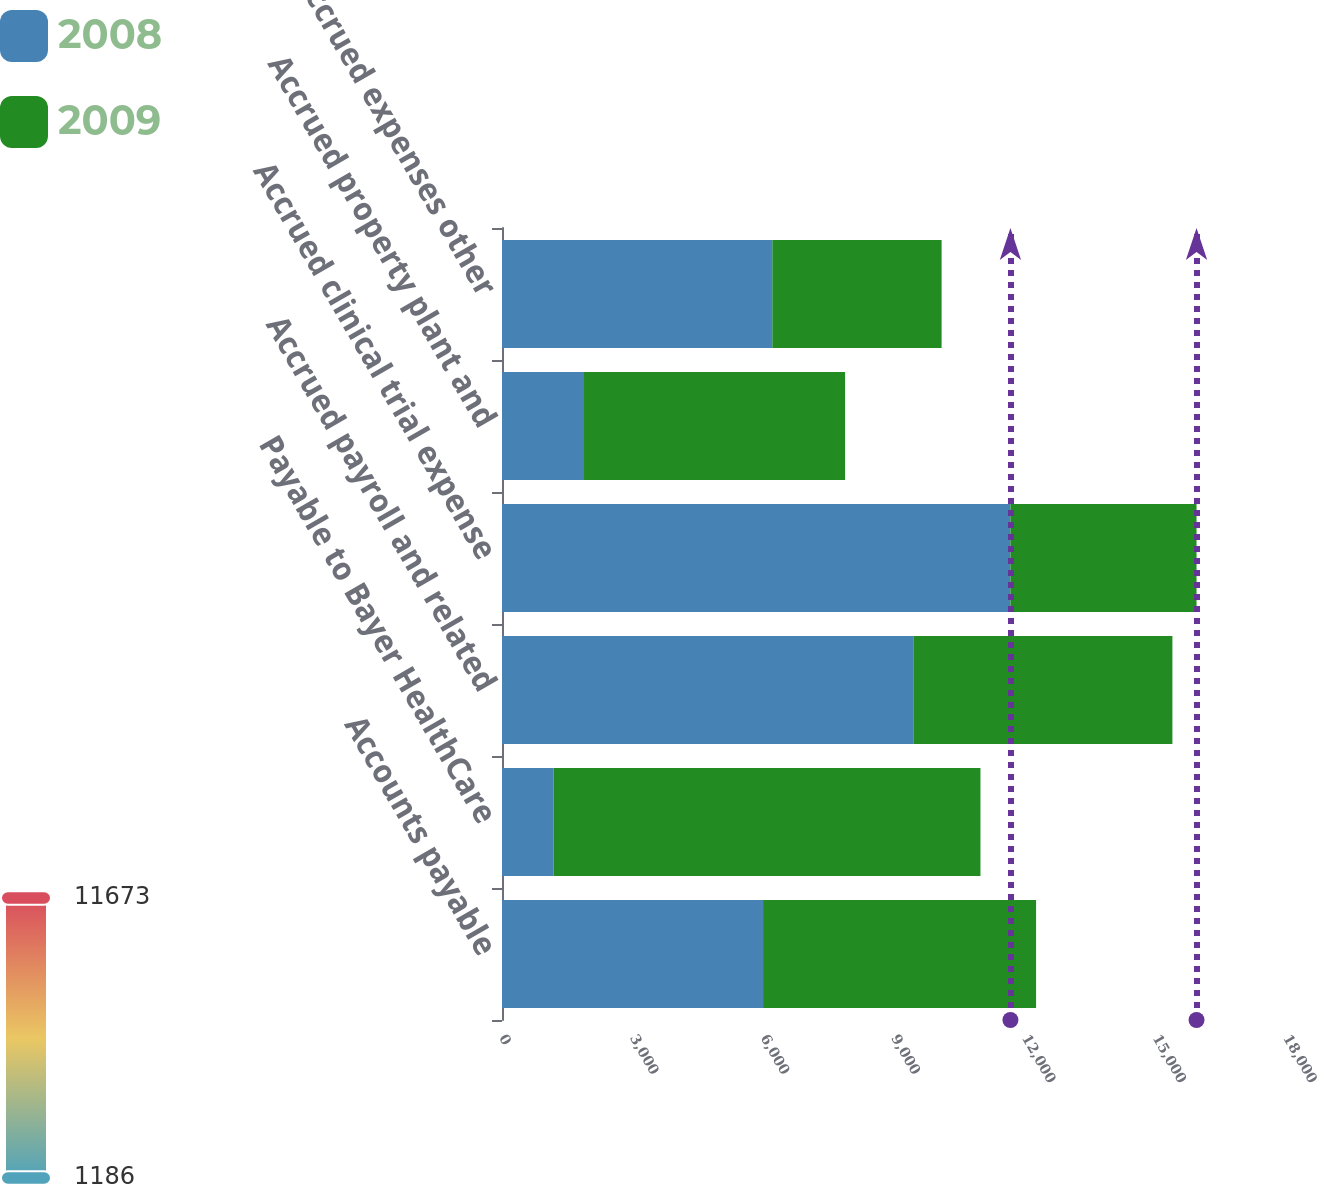<chart> <loc_0><loc_0><loc_500><loc_500><stacked_bar_chart><ecel><fcel>Accounts payable<fcel>Payable to Bayer HealthCare<fcel>Accrued payroll and related<fcel>Accrued clinical trial expense<fcel>Accrued property plant and<fcel>Accrued expenses other<nl><fcel>2008<fcel>5994<fcel>1186<fcel>9444<fcel>11673<fcel>1883<fcel>6207<nl><fcel>2009<fcel>6268<fcel>9799<fcel>5948<fcel>4273<fcel>5994<fcel>3886<nl></chart> 